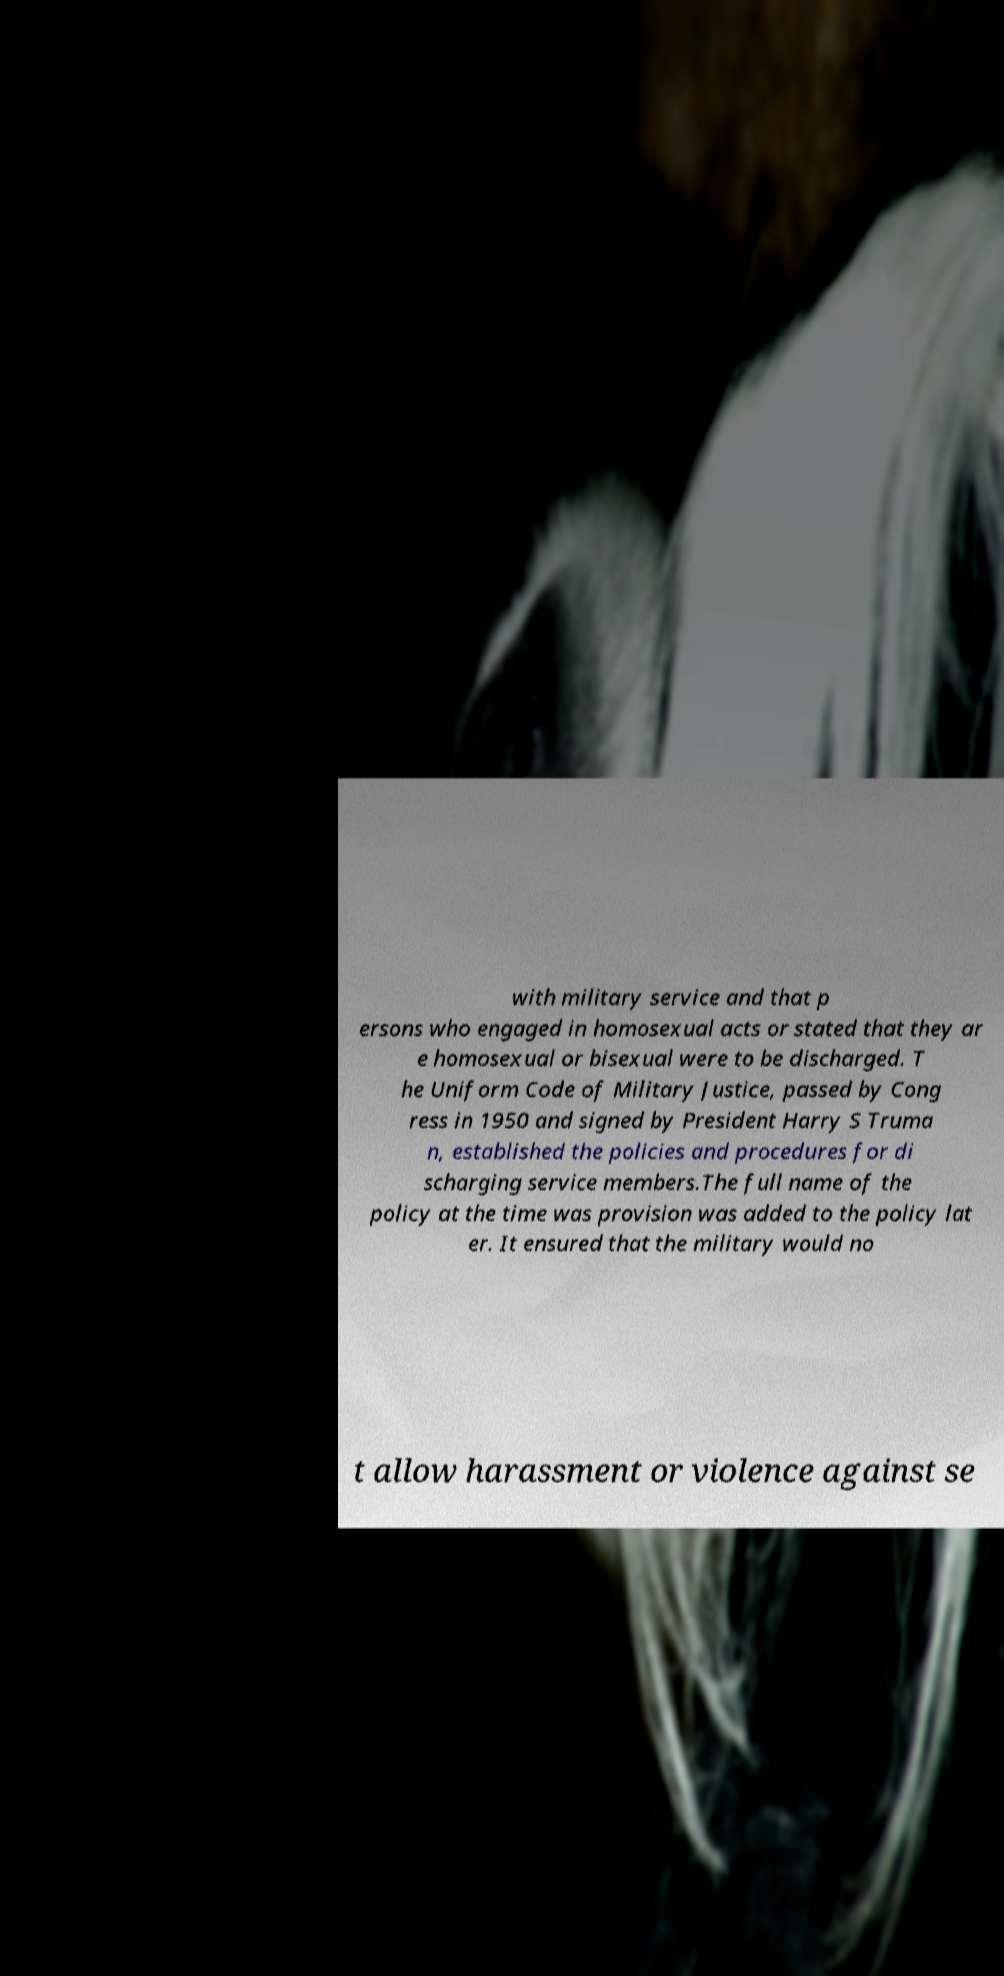I need the written content from this picture converted into text. Can you do that? with military service and that p ersons who engaged in homosexual acts or stated that they ar e homosexual or bisexual were to be discharged. T he Uniform Code of Military Justice, passed by Cong ress in 1950 and signed by President Harry S Truma n, established the policies and procedures for di scharging service members.The full name of the policy at the time was provision was added to the policy lat er. It ensured that the military would no t allow harassment or violence against se 